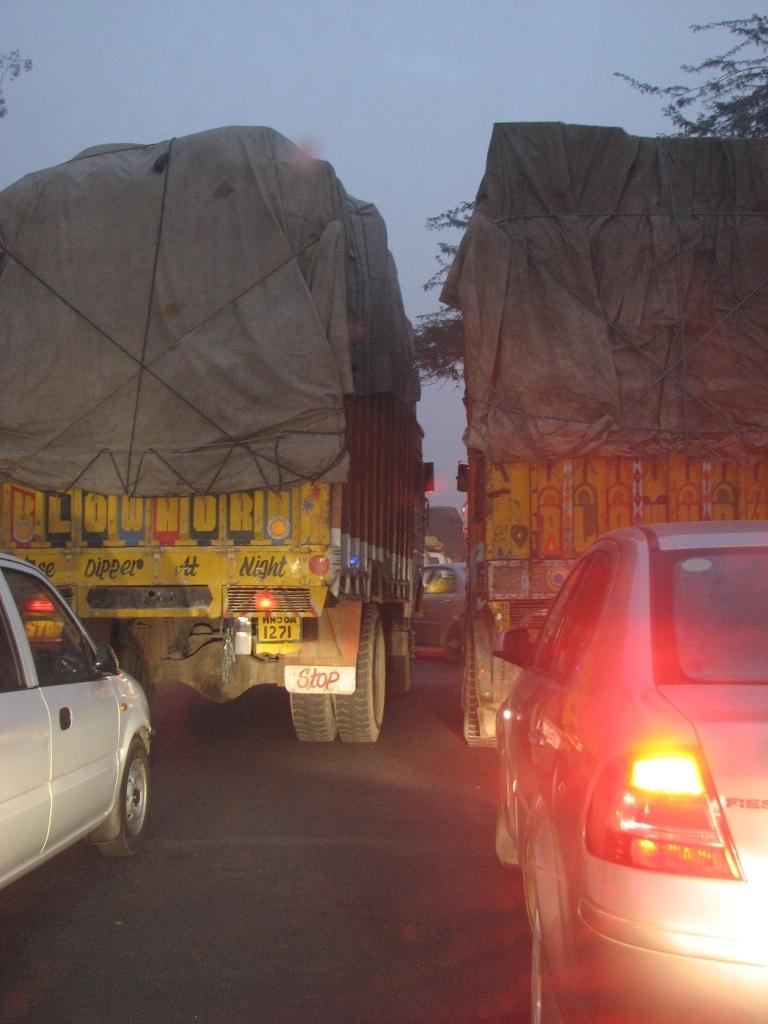What can be seen on the road in the image? There are vehicles on the road in the image. What type of natural scenery is visible in the background of the image? There are trees visible in the background of the image. What type of bun is being used to write the prose in the image? There is no bun or prose present in the image; it features vehicles on the road and trees in the background. 